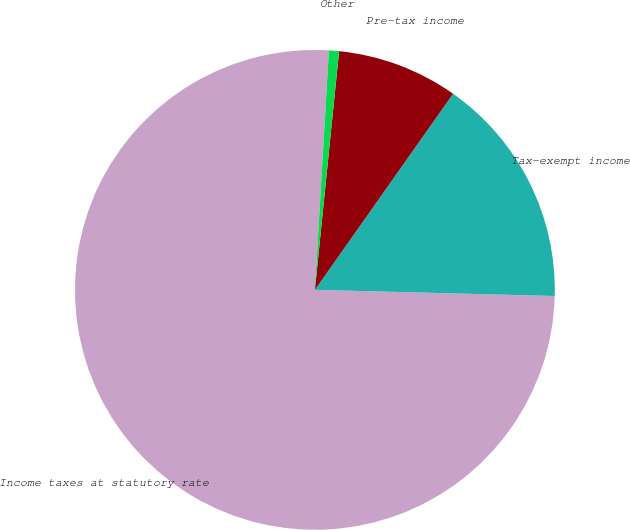<chart> <loc_0><loc_0><loc_500><loc_500><pie_chart><fcel>Income taxes at statutory rate<fcel>Tax-exempt income<fcel>Pre-tax income<fcel>Other<nl><fcel>75.52%<fcel>15.64%<fcel>8.16%<fcel>0.68%<nl></chart> 